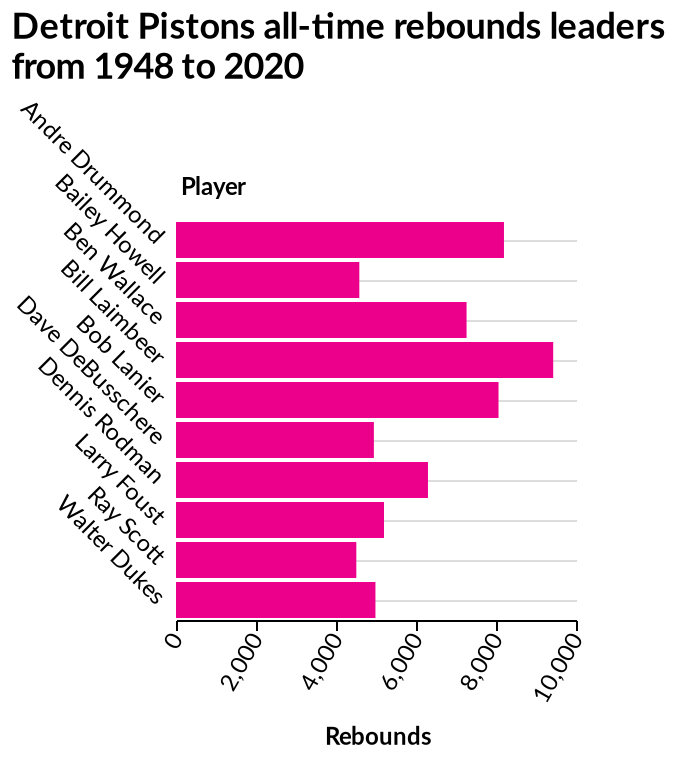<image>
Who is the player with the fewest rebounds in Detroit Pistons history? The player with the fewest rebounds in Detroit Pistons history is Walter Dukes. 